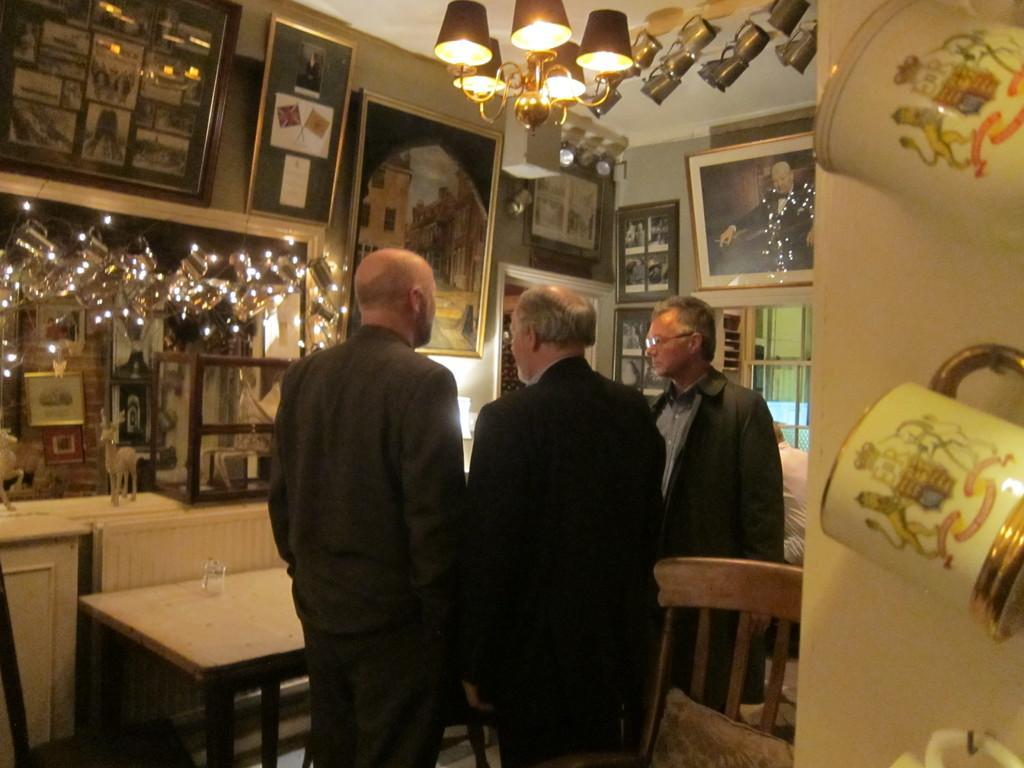Can you describe this image briefly? This picture is clicked inside the room. Here, we see three men standing and talking. Beside them, we see man in white shirt is sitting on chair and in front of them, we see table on which glass is placed. On the right corner of the picture, we see cups which are hanged to the nails on the wall. On the left side of the picture, we see a table on which deer toy is placed and we even see many photo frames placed on the wall. 